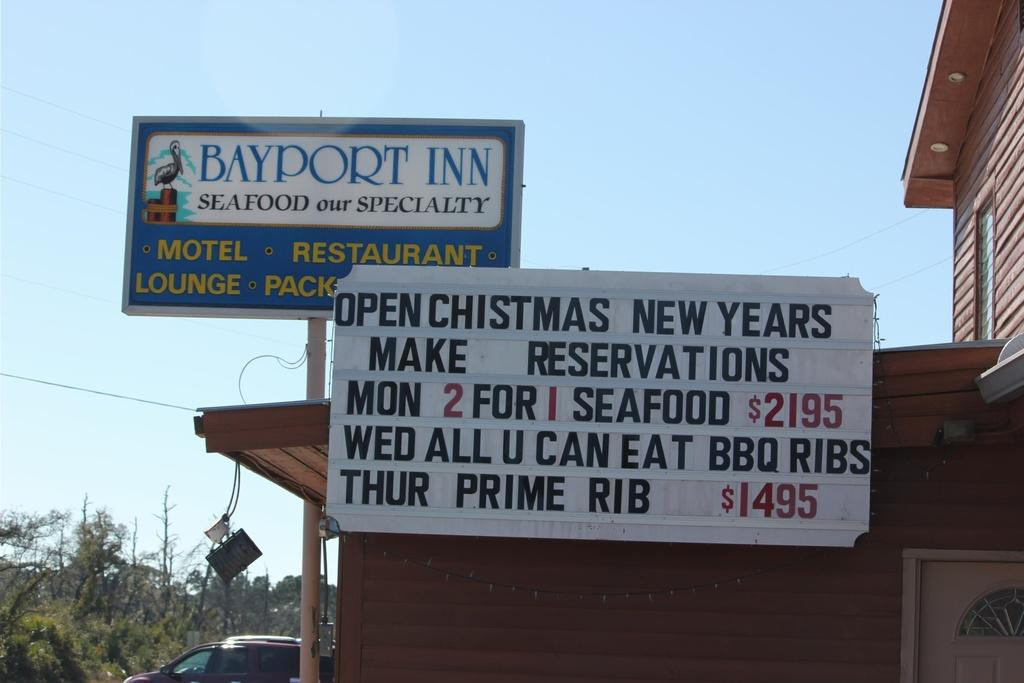<image>
Present a compact description of the photo's key features. A hotel sign that says Bayport Inn Seafood our Specialty. 